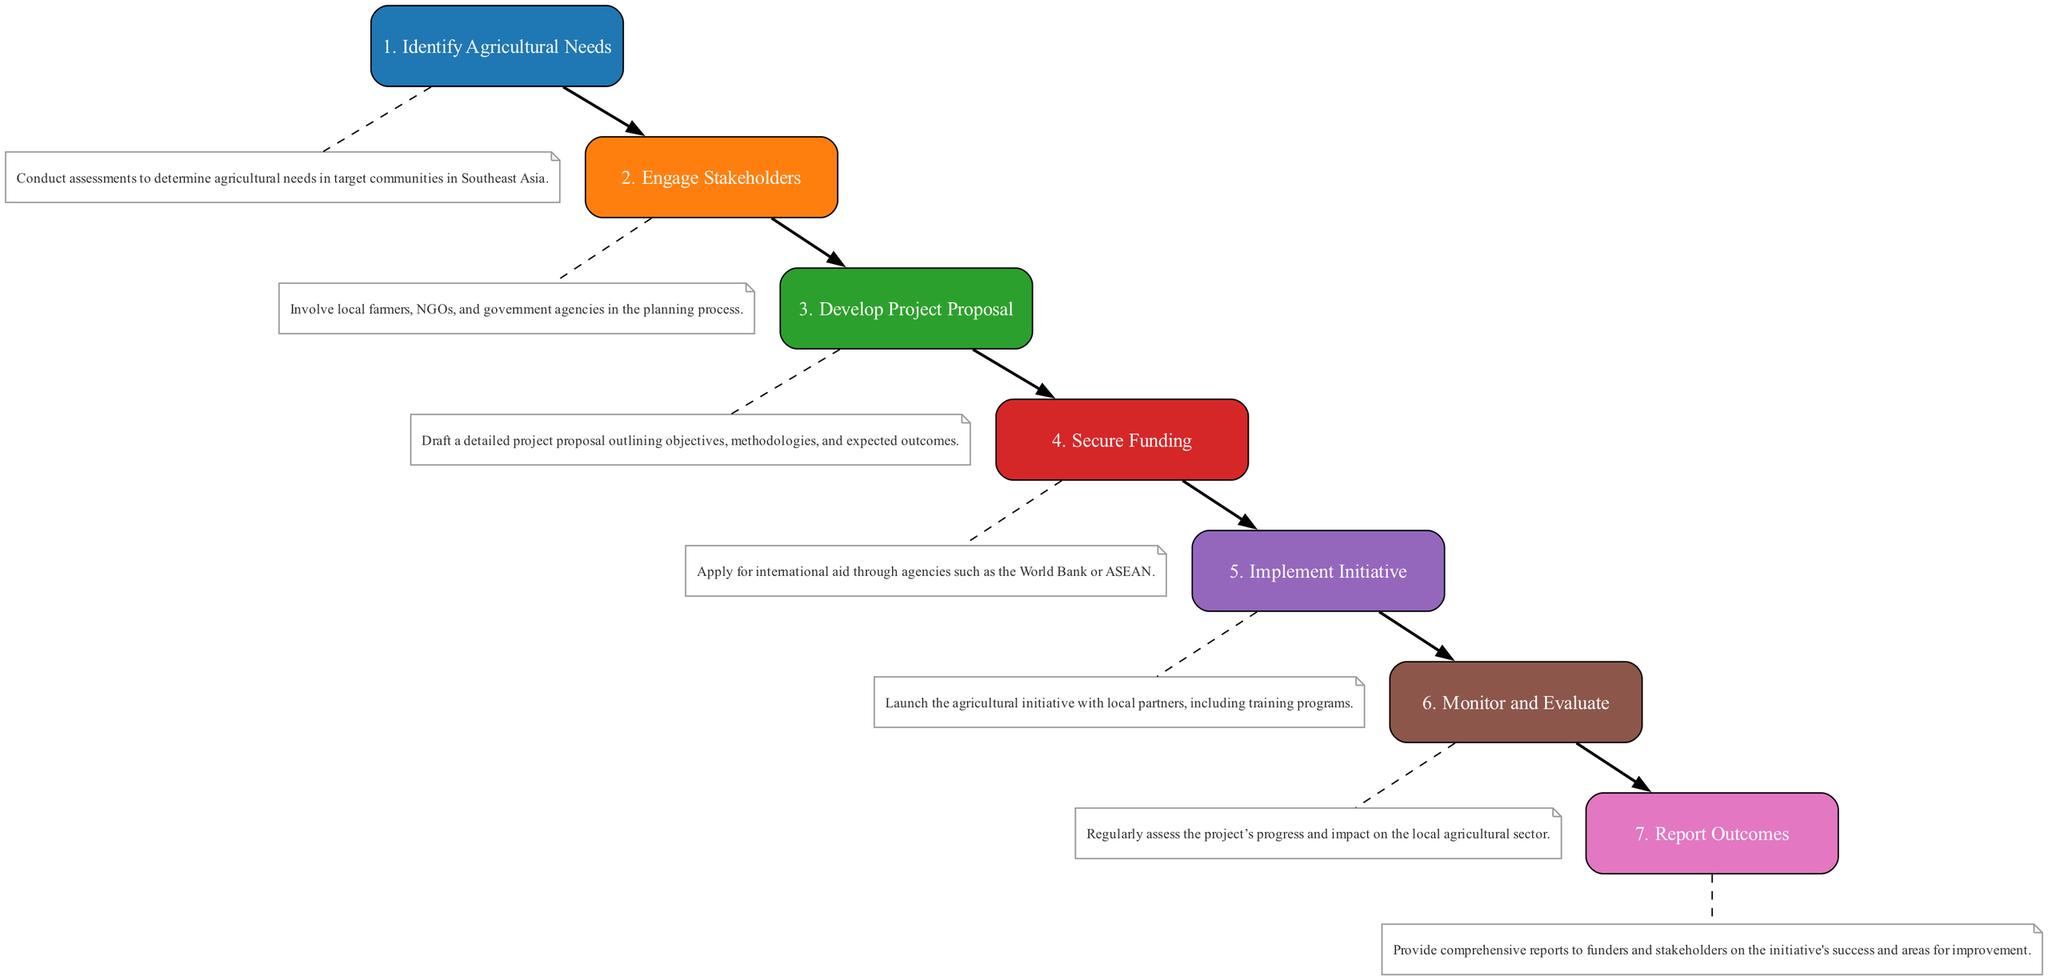What is the first step in the agricultural initiative? The diagram lists the steps in a sequential manner, and the first step is clearly labeled as "Identify Agricultural Needs."
Answer: Identify Agricultural Needs How many total steps are involved in the initiative? By counting the nodes in the diagram, we find that there are a total of seven steps from "Identify Agricultural Needs" to "Report Outcomes."
Answer: Seven Which step follows "Secure Funding"? The diagram shows a direct connection from "Secure Funding" to "Implement Initiative," indicating that "Implement Initiative" is the subsequent step.
Answer: Implement Initiative What is the last step of the process? The last node in the diagram is "Report Outcomes," which indicates it is the final step in the sequence of the agricultural initiative.
Answer: Report Outcomes What type of stakeholders are engaged in the second step? The description of "Engage Stakeholders" mentions local farmers, NGOs, and government agencies, indicating the types of stakeholders involved.
Answer: Local farmers, NGOs, and government agencies Describe the monitoring activity in the initiative. The step "Monitor and Evaluate" involves regularly assessing the project’s progress and its impact, which is a key aspect of the monitoring activity.
Answer: Regularly assess progress and impact How does "Develop Project Proposal" relate to "Secure Funding"? The diagram indicates a sequence: after "Develop Project Proposal," which sets the project's goals, the next step logically is to "Secure Funding" based on that proposal.
Answer: Sequentially linked steps What indicates the involvement of local partners in the process? The step "Implement Initiative" explicitly mentions launching the initiative with local partners, highlighting their involvement in this stage of the project.
Answer: Launch with local partners 